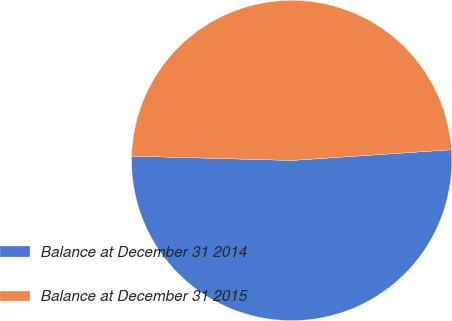Convert chart to OTSL. <chart><loc_0><loc_0><loc_500><loc_500><pie_chart><fcel>Balance at December 31 2014<fcel>Balance at December 31 2015<nl><fcel>51.5%<fcel>48.5%<nl></chart> 